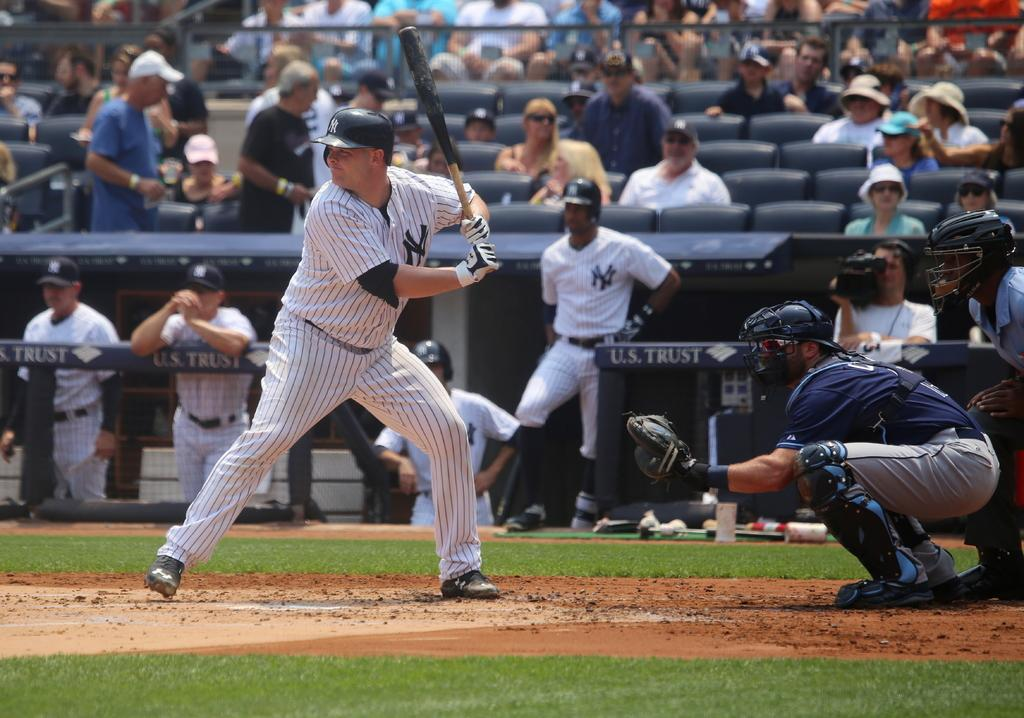<image>
Give a short and clear explanation of the subsequent image. The sponsor behind the baseball player who is batting is U.S. Trust 